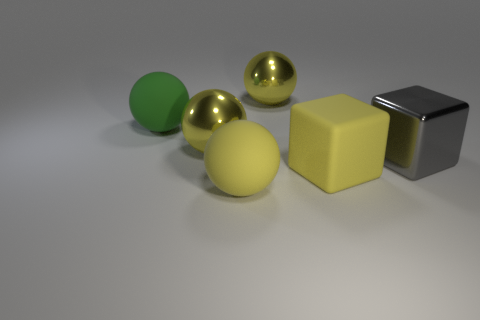How many yellow balls must be subtracted to get 1 yellow balls? 2 Add 3 large cyan blocks. How many objects exist? 9 Subtract all big yellow spheres. How many spheres are left? 1 Subtract all brown cylinders. How many yellow cubes are left? 1 Subtract all large gray blocks. Subtract all big yellow metallic balls. How many objects are left? 3 Add 2 large gray shiny things. How many large gray shiny things are left? 3 Add 1 large yellow rubber balls. How many large yellow rubber balls exist? 2 Subtract all green balls. How many balls are left? 3 Subtract 0 blue balls. How many objects are left? 6 Subtract all balls. How many objects are left? 2 